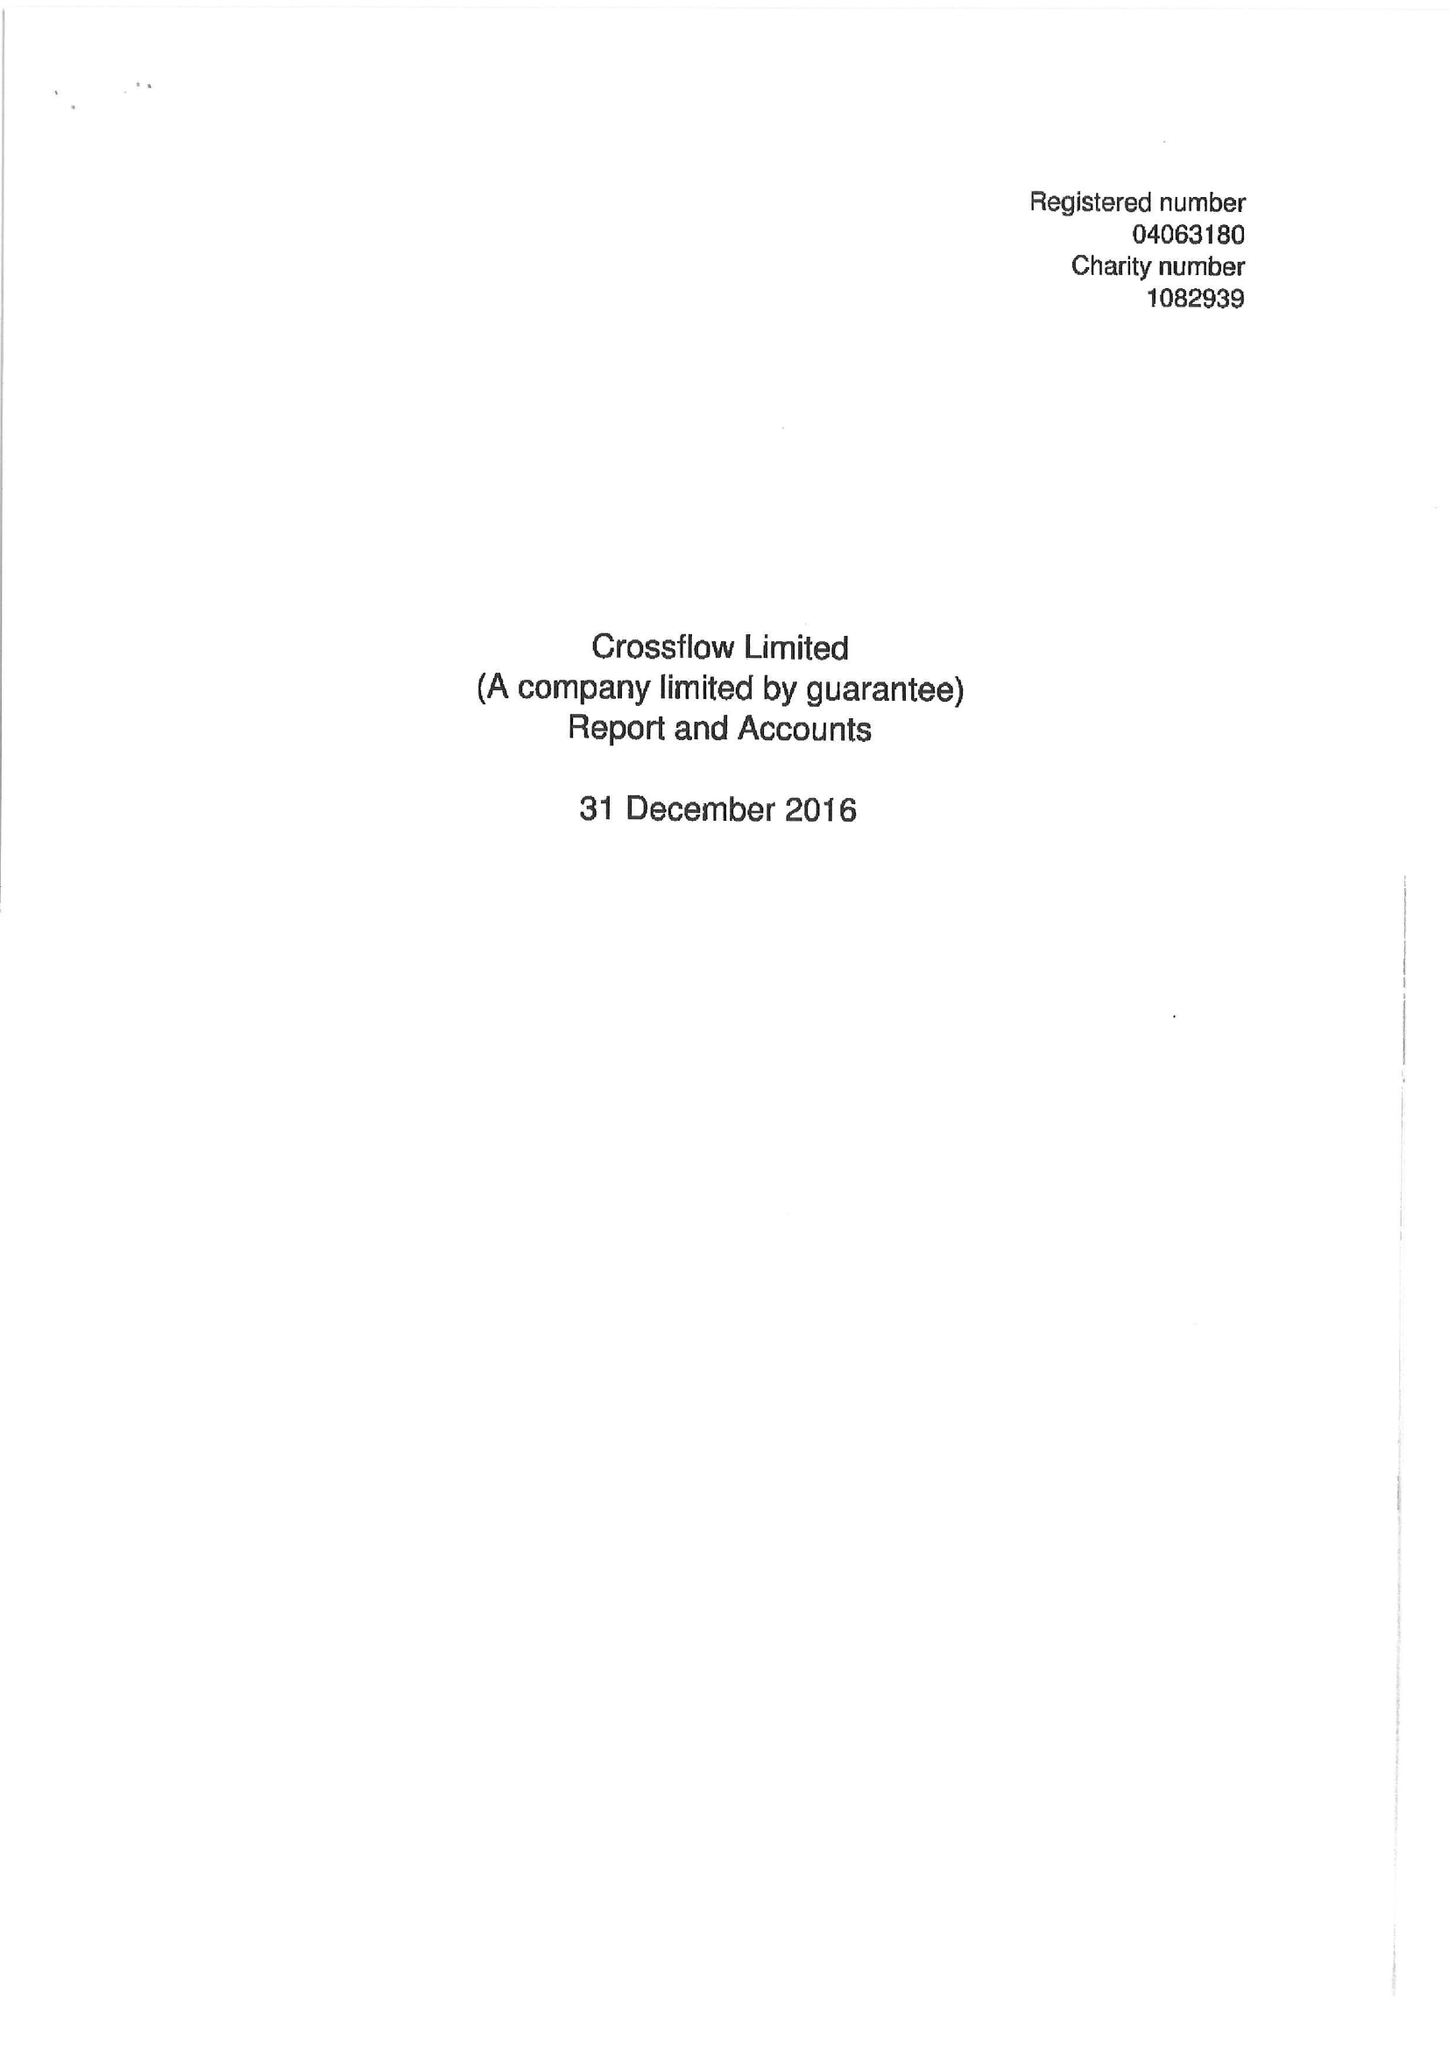What is the value for the charity_number?
Answer the question using a single word or phrase. 1082939 